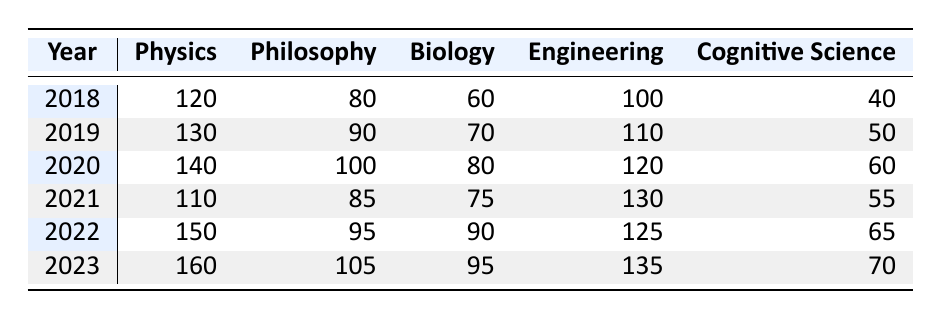What was the highest participation in Physics across the years? In reviewing the table, the participation in Physics peaks at 160 in the year 2023.
Answer: 160 Which discipline had the lowest participation in 2019? Looking at the 2019 row, the participation numbers are 130 for Physics, 90 for Philosophy, 70 for Biology, 110 for Engineering, and 50 for Cognitive Science. The lowest number is 50, which corresponds to Cognitive Science.
Answer: Cognitive Science What was the total participation in Engineering from 2018 to 2023? The participation numbers for Engineering over the years are 100 (2018), 110 (2019), 120 (2020), 130 (2021), 125 (2022), and 135 (2023). The total is 100 + 110 + 120 + 130 + 125 + 135 = 720.
Answer: 720 Did Philosophy experience an increase in participation from 2020 to 2023? In 2020, participation in Philosophy was 100, and in 2023 it increased to 105, indicating an increase over that period.
Answer: Yes What is the average participation in Biology from 2018 to 2022? The Biology participation numbers for the years 2018 through 2022 are 60, 70, 80, 75, and 90. To find the average, sum these values (60 + 70 + 80 + 75 + 90 = 375) and divide by the number of years (375 / 5 = 75).
Answer: 75 